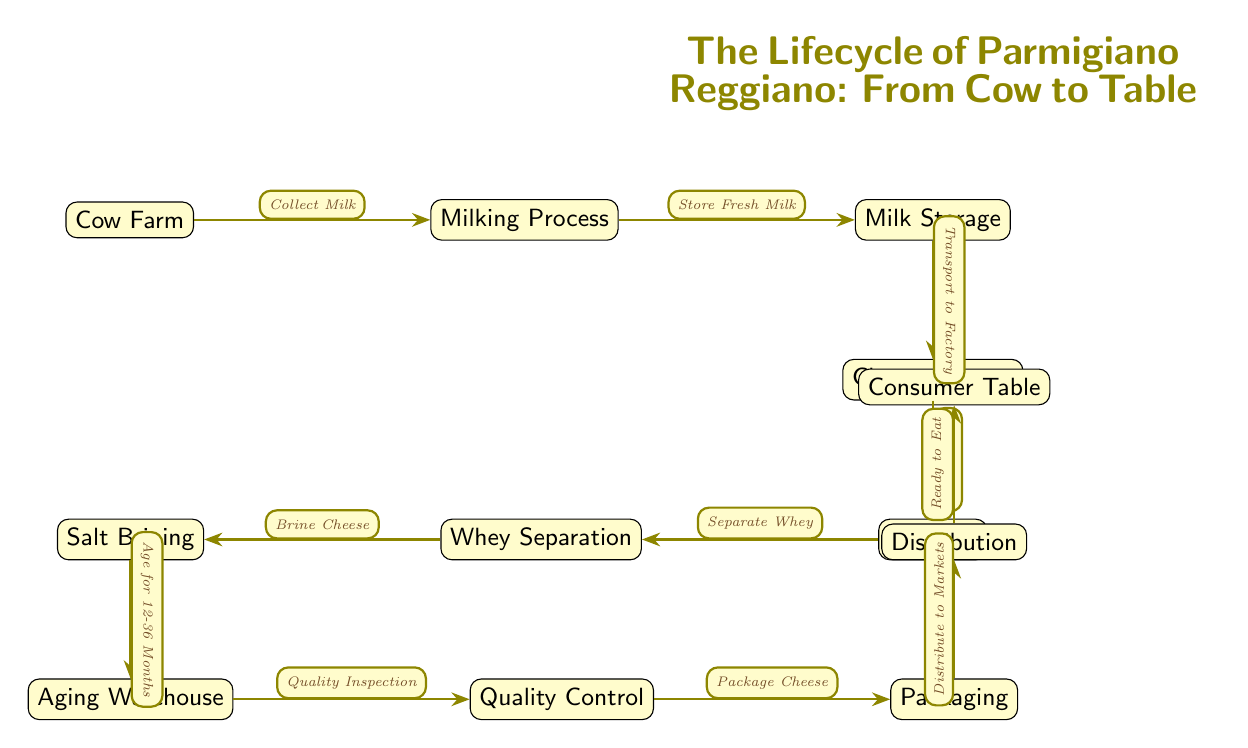What is the first step in the lifecycle of Parmigiano Reggiano? The first node in the diagram is "Cow Farm," which indicates that the lifecycle begins with the cows.
Answer: Cow Farm How many total nodes are in the diagram? By counting each individual step in the diagram, there are 11 nodes: Cow Farm, Milking Process, Milk Storage, Cheese Factory, Curdling, Whey Separation, Salt Brining, Aging Warehouse, Quality Control, Packaging, and Distribution.
Answer: 11 What process comes after "Whey Separation"? From the diagram, the flow from the "Whey Separation" node leads directly to the "Salt Brining" node, indicating that salt brining follows whey separation in the lifecycle.
Answer: Salt Brining Which step is the last before the cheese reaches the consumer? The last step before the cheese reaches the consumer in the flowchart is "Distribution," which shows that the product must go through this phase before reaching the consumer table.
Answer: Distribution What is the duration cheese is aged according to the diagram? The "Aging Warehouse" node states "Age for 12-36 Months," indicating that this is the aging duration required for Parmigiano Reggiano cheese.
Answer: 12-36 Months Where does the "Quality Control" come in the diagram? The "Quality Control" node follows the "Aging Warehouse" and comes before the "Packaging," indicating that it occurs after aging and before packaging in the production cycle.
Answer: Between Aging Warehouse and Packaging What happens to the milk after "Milking Process"? After the "Milking Process," the next step indicated in the diagram is "Milk Storage," which shows that the milk is stored after it has been collected from the cows.
Answer: Milk Storage How is the cheese made from milk in the lifecycle? The process involves first curdling the milk in the "Cheese Factory," which is the step taken immediately after "Milk Storage."
Answer: Curdling 